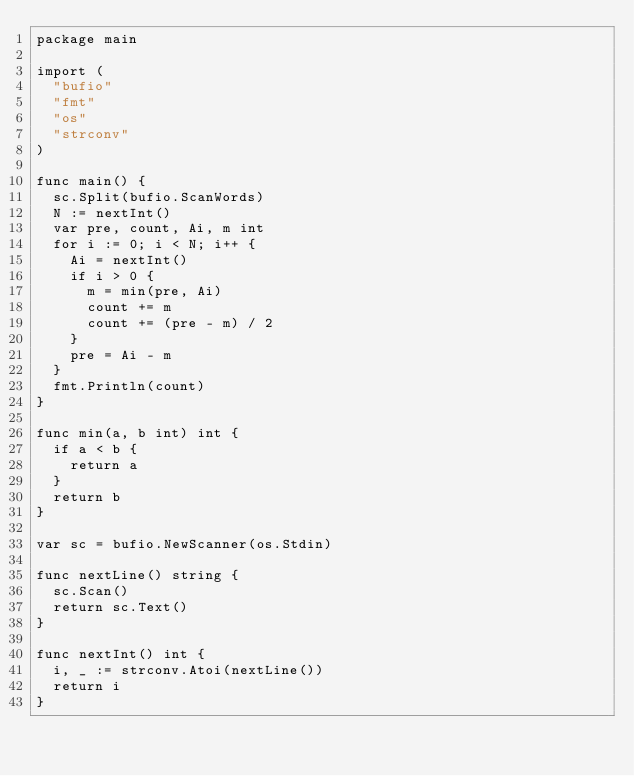<code> <loc_0><loc_0><loc_500><loc_500><_Go_>package main

import (
	"bufio"
	"fmt"
	"os"
	"strconv"
)

func main() {
	sc.Split(bufio.ScanWords)
	N := nextInt()
	var pre, count, Ai, m int
	for i := 0; i < N; i++ {
		Ai = nextInt()
		if i > 0 {
			m = min(pre, Ai)
			count += m
			count += (pre - m) / 2
		}
		pre = Ai - m
	}
	fmt.Println(count)
}

func min(a, b int) int {
	if a < b {
		return a
	}
	return b
}

var sc = bufio.NewScanner(os.Stdin)

func nextLine() string {
	sc.Scan()
	return sc.Text()
}

func nextInt() int {
	i, _ := strconv.Atoi(nextLine())
	return i
}
</code> 